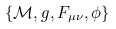Convert formula to latex. <formula><loc_0><loc_0><loc_500><loc_500>\{ \mathcal { M } , g , F _ { \mu \nu } , \phi \}</formula> 